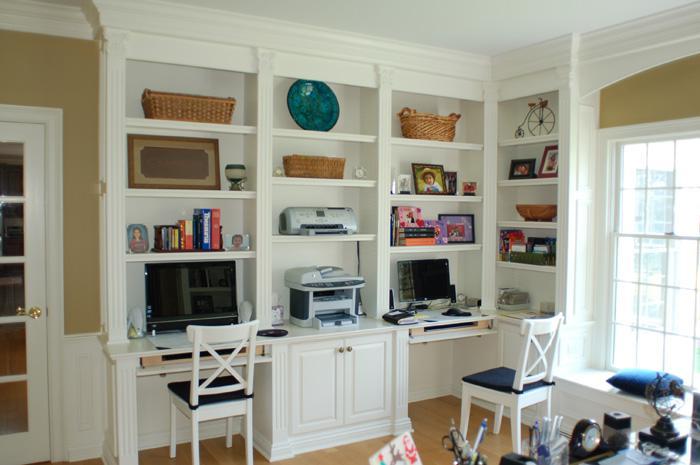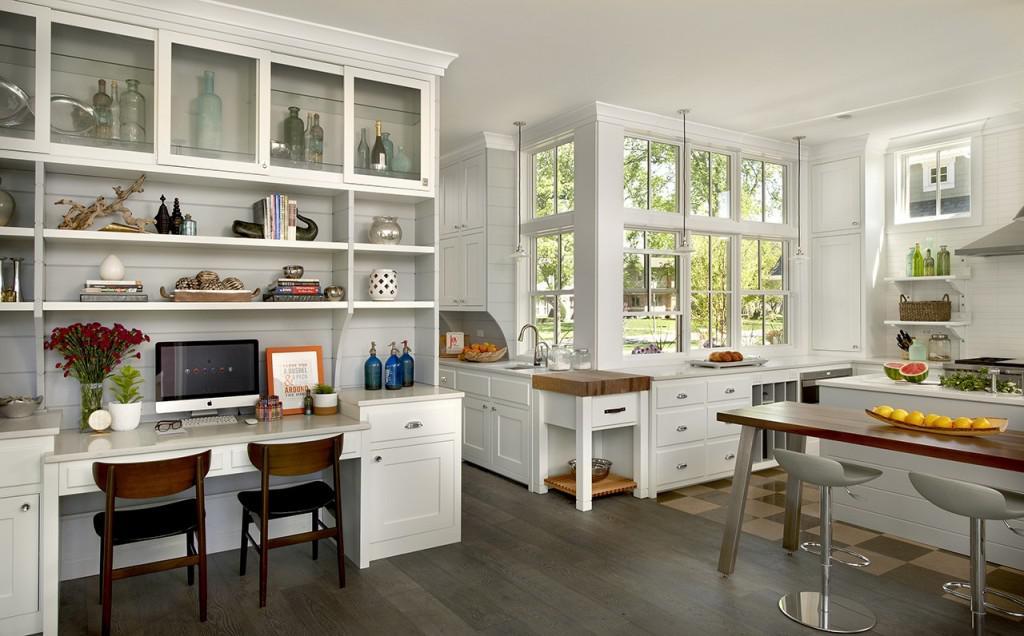The first image is the image on the left, the second image is the image on the right. Considering the images on both sides, is "An image shows a desk topped with a monitor and coupled with brown shelves for books." valid? Answer yes or no. No. The first image is the image on the left, the second image is the image on the right. Given the left and right images, does the statement "At least two woode chairs are by a computer desk." hold true? Answer yes or no. Yes. 